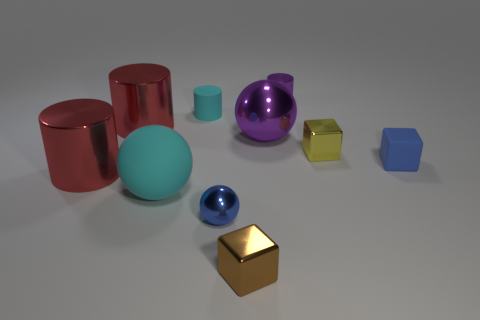What is the color of the metal cylinder that is to the left of the large purple thing and behind the small blue rubber object?
Offer a terse response. Red. How big is the cyan cylinder?
Your response must be concise. Small. There is a metallic block that is behind the blue sphere; is its color the same as the large matte object?
Offer a very short reply. No. Are there more red cylinders that are in front of the tiny yellow block than blue cubes behind the tiny purple cylinder?
Offer a very short reply. Yes. Is the number of tiny cyan rubber spheres greater than the number of small cyan things?
Your response must be concise. No. There is a metal object that is both right of the small brown shiny block and in front of the big purple metallic sphere; how big is it?
Keep it short and to the point. Small. The small cyan thing has what shape?
Your answer should be very brief. Cylinder. Is there anything else that has the same size as the blue rubber cube?
Your response must be concise. Yes. Are there more cyan things that are in front of the cyan matte cylinder than tiny rubber cylinders?
Keep it short and to the point. No. There is a tiny thing that is to the left of the blue thing on the left side of the small cube that is on the right side of the yellow metal object; what shape is it?
Provide a succinct answer. Cylinder. 